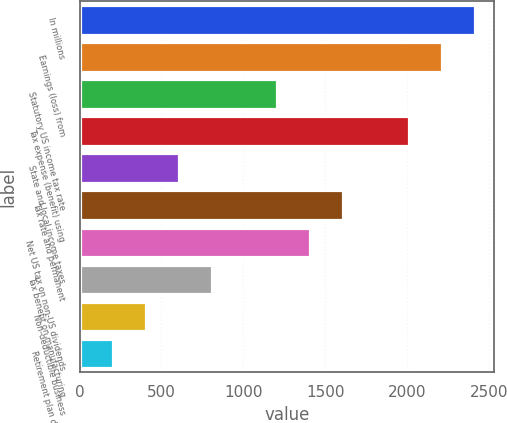Convert chart. <chart><loc_0><loc_0><loc_500><loc_500><bar_chart><fcel>In millions<fcel>Earnings (loss) from<fcel>Statutory US income tax rate<fcel>Tax expense (benefit) using<fcel>State and local income taxes<fcel>Tax rate and permanent<fcel>Net US tax on non-US dividends<fcel>Tax benefit on manufacturing<fcel>Non-deductible business<fcel>Retirement plan dividends<nl><fcel>2413.6<fcel>2212.8<fcel>1208.8<fcel>2012<fcel>606.4<fcel>1610.4<fcel>1409.6<fcel>807.2<fcel>405.6<fcel>204.8<nl></chart> 